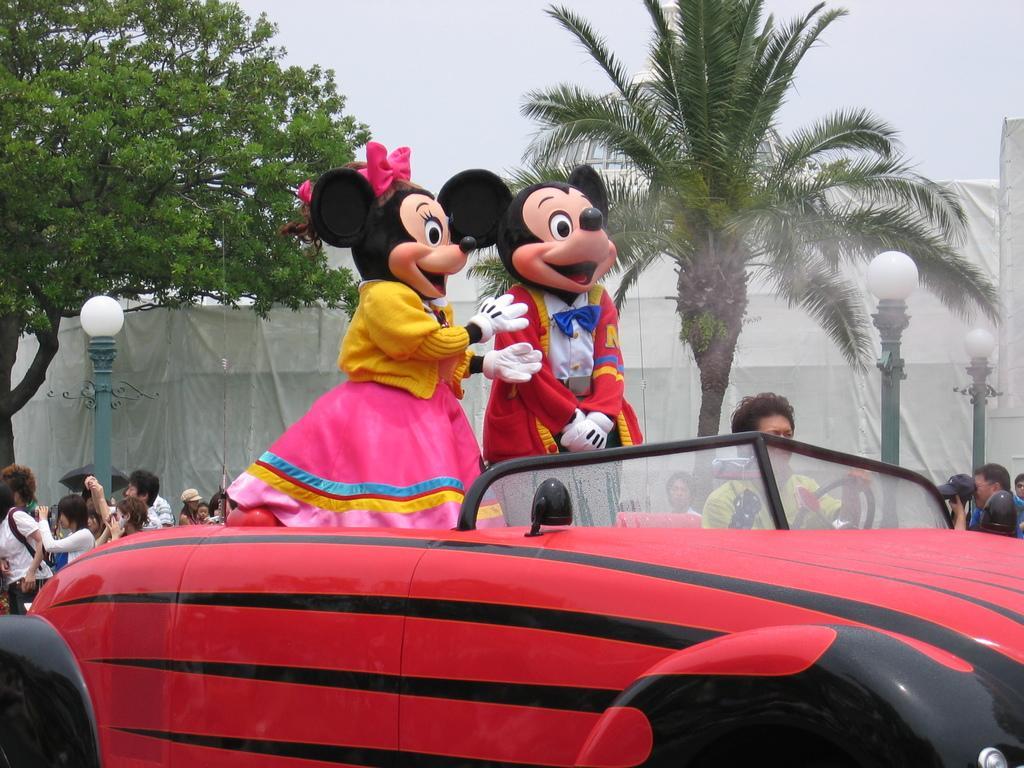Describe this image in one or two sentences. In this picture I can see two mickey mouse costumes on a vehicle. In the background I can see group of people, lights, trees and the sky. 